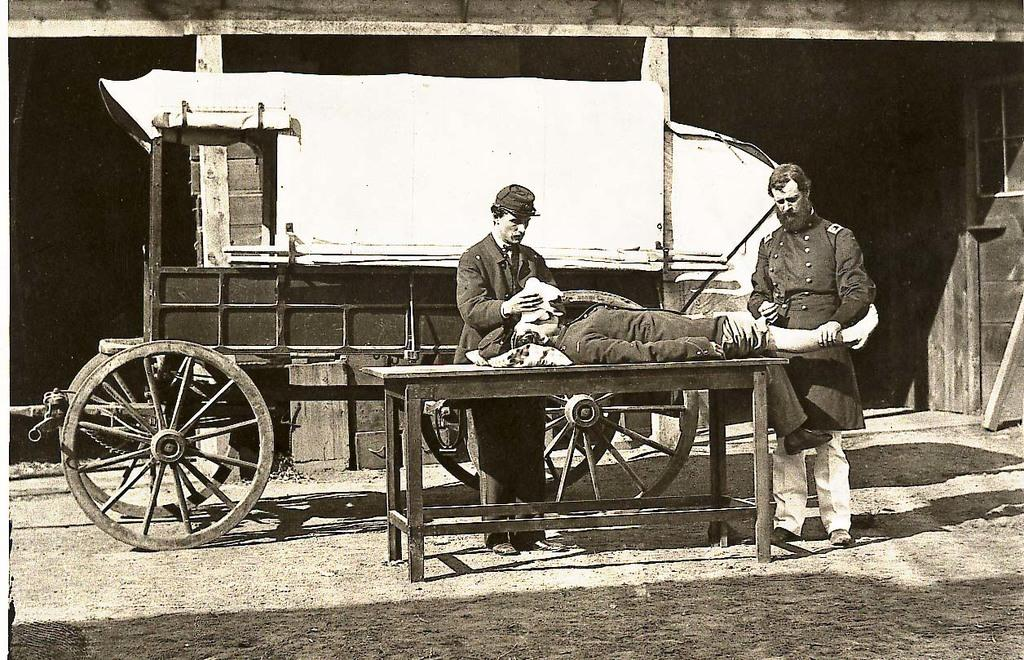How many people are present in the image? There are three people in the image. What are the positions of the people in the image? Two people are standing, and one person is lying down. What can be observed about the clothing of the people in the image? All three people are wearing clothes. What can be seen on the head of the person on the left side? The person on the left side is wearing a cap. What type of furniture is present in the image? There is a table in the image. What type of vehicle is present in the image? There is a cart in the image. What part of the cart is visible in the image? Wheels are visible in the image. How many geese are walking on the trail in the image? There are no geese or trails present in the image. What type of ground is visible beneath the people in the image? The ground is not visible in the image; only the people, furniture, and vehicle are present. 